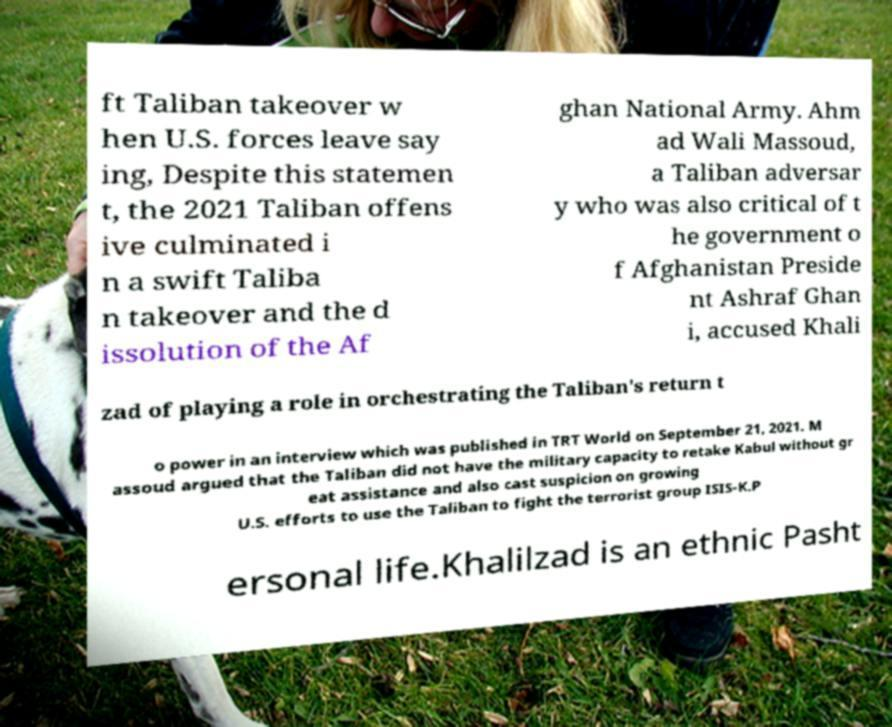Please read and relay the text visible in this image. What does it say? ft Taliban takeover w hen U.S. forces leave say ing, Despite this statemen t, the 2021 Taliban offens ive culminated i n a swift Taliba n takeover and the d issolution of the Af ghan National Army. Ahm ad Wali Massoud, a Taliban adversar y who was also critical of t he government o f Afghanistan Preside nt Ashraf Ghan i, accused Khali zad of playing a role in orchestrating the Taliban's return t o power in an interview which was published in TRT World on September 21, 2021. M assoud argued that the Taliban did not have the military capacity to retake Kabul without gr eat assistance and also cast suspicion on growing U.S. efforts to use the Taliban to fight the terrorist group ISIS-K.P ersonal life.Khalilzad is an ethnic Pasht 